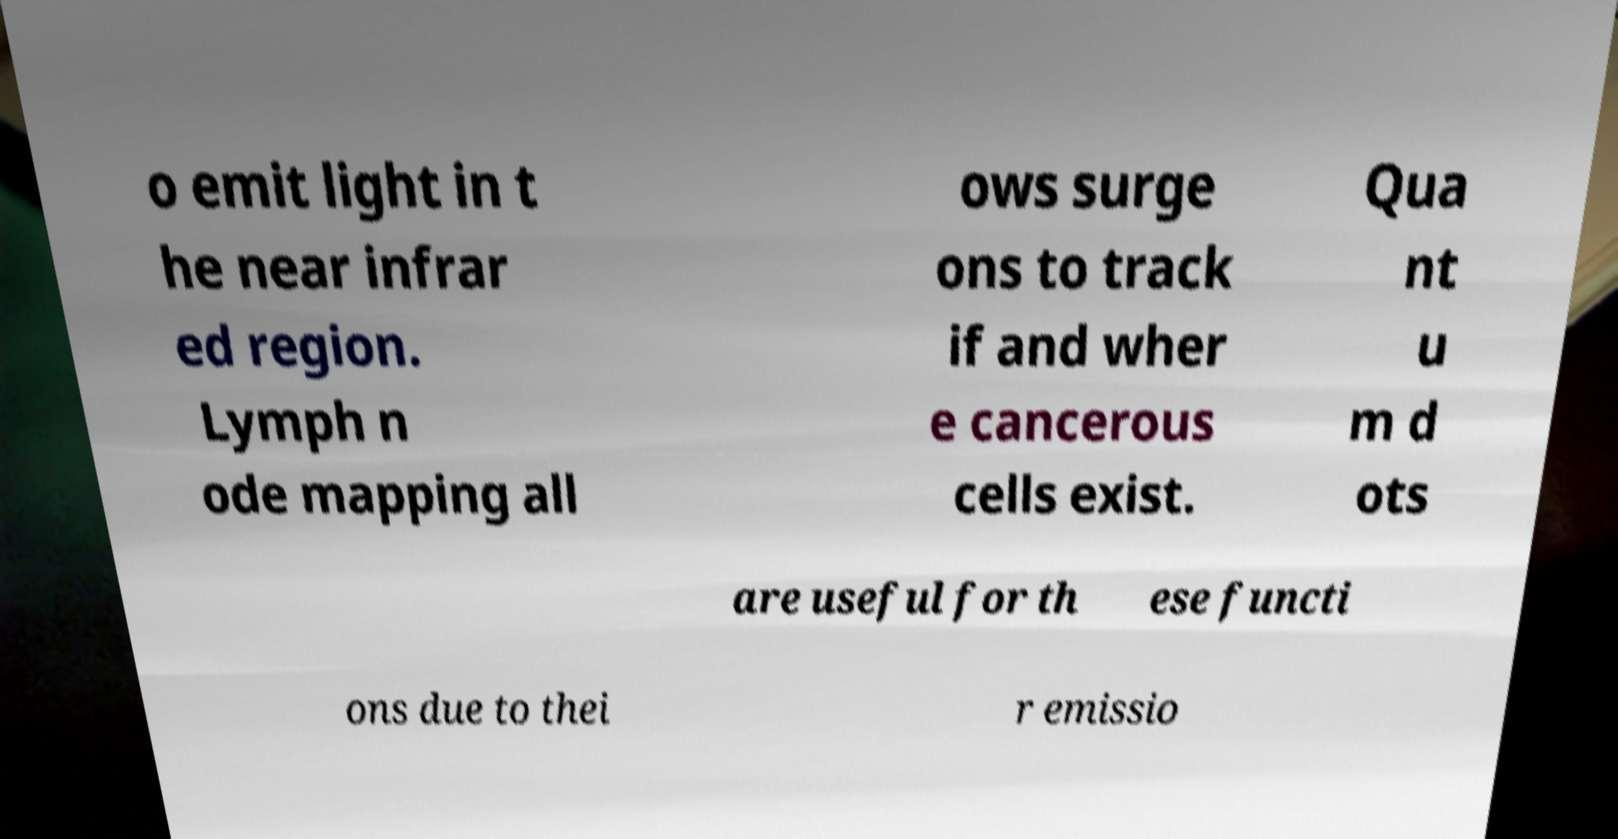What messages or text are displayed in this image? I need them in a readable, typed format. o emit light in t he near infrar ed region. Lymph n ode mapping all ows surge ons to track if and wher e cancerous cells exist. Qua nt u m d ots are useful for th ese functi ons due to thei r emissio 